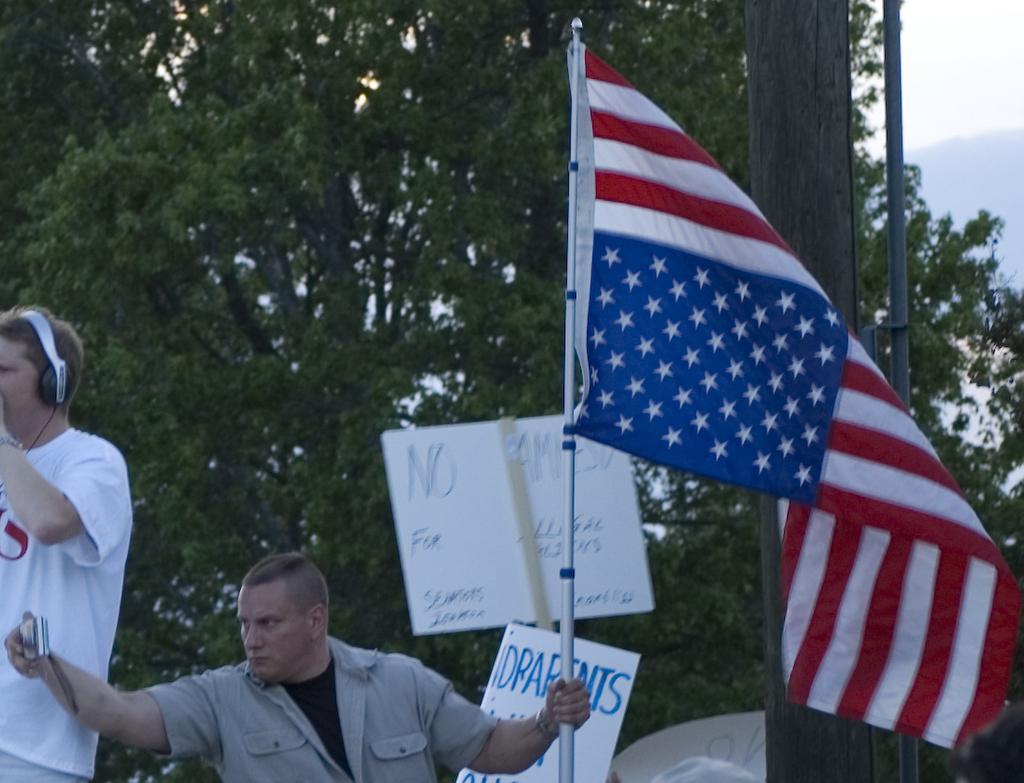Please provide a concise description of this image. Here in the middle we can see a person holding a flag post in one hand and a camera in other hand and beside him also we can see another person with headset on him and behind them we can see ply cards all over there and we can see a pole and trees present behind them all over there. 